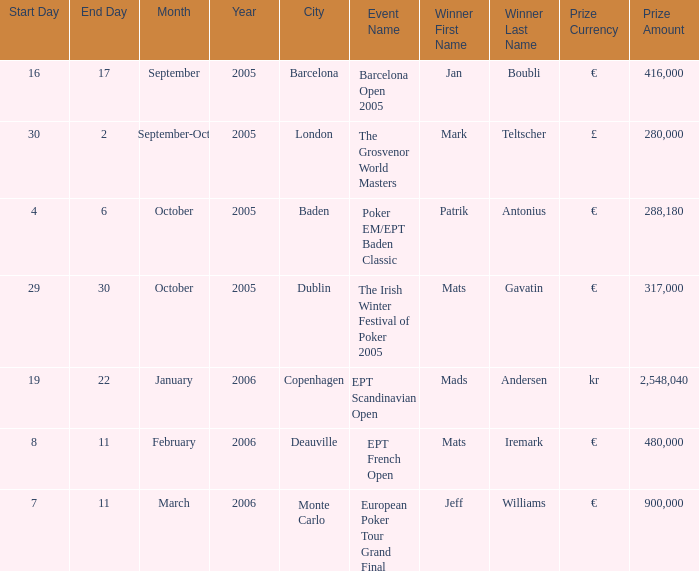In which city did an occurrence offer a reward of €288,180? Baden. 